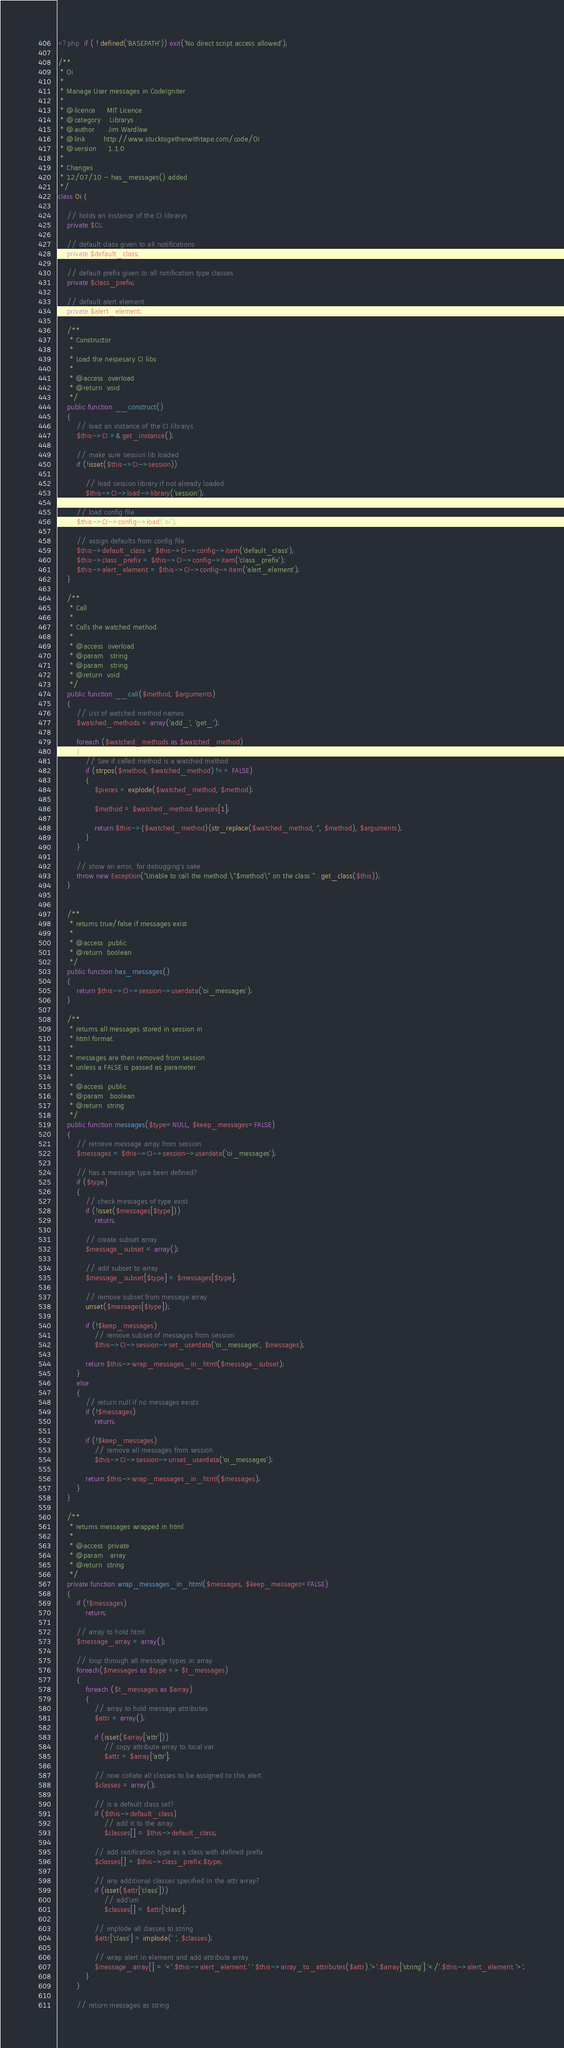<code> <loc_0><loc_0><loc_500><loc_500><_PHP_><?php  if ( ! defined('BASEPATH')) exit('No direct script access allowed');

/**
 * Oi
 *
 * Manage User messages in CodeIgniter
 *
 * @licence 	MIT Licence
 * @category	Librarys 
 * @author		Jim Wardlaw
 * @link		http://www.stucktogetherwithtape.com/code/Oi
 * @version 	1.1.0
 *
 * Changes
 * 12/07/10	- has_messages() added
 */ 
class Oi {
	
	// holds an instance of the CI librarys
	private $CI; 		

	// default class given to all notifications
	private $default_class;
	
	// default prefix given to all notification type classes
	private $class_prefix;
	
	// default alert element
	private $alert_element;

	/**
	 * Constructor
	 *
	 * Load the nessesary CI libs
	 *
	 * @access	overload
	 * @return	void
	 */	
	public function __construct()
	{
		// load an instance of the CI librarys
		$this->CI =& get_instance();
		
		// make sure session lib loaded
		if (!isset($this->CI->session))
		
			// load session library if not already loaded
			$this->CI->load->library('session');
			
		// load config file
		$this->CI->config->load('oi');
		
		// assign defaults from config file
		$this->default_class = $this->CI->config->item('default_class');		
		$this->class_prefix = $this->CI->config->item('class_prefix');		
		$this->alert_element = $this->CI->config->item('alert_element');
	}
	
	/**
	 * Call
	 *
	 * Calls the watched method.
	 *
	 * @access	overload
	 * @param	string
	 * @param	string
	 * @return	void
	 */
	public function __call($method, $arguments)
	{		
		// List of watched method names
		$watched_methods = array('add_', 'get_');

		foreach ($watched_methods as $watched_method)
		{
			// See if called method is a watched method
			if (strpos($method, $watched_method) !== FALSE)
			{
				$pieces = explode($watched_method, $method);
				
				$method = $watched_method.$pieces[1];
								
				return $this->{$watched_method}(str_replace($watched_method, '', $method), $arguments);
			}
		}
				
		// show an error, for debugging's sake.
		throw new Exception("Unable to call the method \"$method\" on the class " . get_class($this));
	}


	/**
	 * returns true/false if messages exist
	 *
	 * @access	public
	 * @return	boolean
	 */
	public function has_messages()
	{
		return $this->CI->session->userdata('oi_messages');
	}

	/**
	 * returns all messages stored in session in
	 * html format.
	 *
	 * messages are then removed from session
	 * unless a FALSE is passed as parameter
	 *
	 * @access	public
	 * @param	boolean
	 * @return	string
	 */
	public function messages($type=NULL, $keep_messages=FALSE)
	{
		// retrieve message array from session
		$messages = $this->CI->session->userdata('oi_messages');
		
		// has a message type been defined?
		if ($type)
		{
			// check messages of type exist
			if (!isset($messages[$type]))
				return;
			
			// create subset array
			$message_subset = array();
			
			// add subset to array
			$message_subset[$type] = $messages[$type];
			
			// remove subset from message array
			unset($messages[$type]);
			
			if (!$keep_messages)
				// remove subset of messages from session
				$this->CI->session->set_userdata('oi_messages', $messages);
			
			return $this->wrap_messages_in_html($message_subset);				
		}
		else
		{
			// return null if no messages exists
			if (!$messages)
				return;
				
			if (!$keep_messages)
				// remove all messages from session
				$this->CI->session->unset_userdata('oi_messages');
				
			return $this->wrap_messages_in_html($messages);
		}
	}

	/**
	 * returns messages wrapped in html
	 *
	 * @access	private
	 * @param	array
	 * @return	string
	 */	
	private function wrap_messages_in_html($messages, $keep_messages=FALSE)
	{
		if (!$messages)
			return;
			
		// array to hold html
		$message_array = array();
			
		// loop through all message types in array
		foreach($messages as $type => $t_messages)
		{			
			foreach ($t_messages as $array)
			{
				// array to hold message attributes
				$attr = array();
							
				if (isset($array['attr']))
					// copy attribute array to local var
					$attr = $array['attr'];
					
				// now collate all classes to be assigned to this alert
				$classes = array();
				
				// is a default class set?
				if ($this->default_class)
					// add it to the array
					$classes[] = $this->default_class;
					
				// add notification type as a class with defined prefix
				$classes[] = $this->class_prefix.$type;
				
				// any additional classes specified in the attr array?
				if (isset($attr['class']))
					// add'um
					$classes[] = $attr['class'];
				
				// implode all classes to string
				$attr['class'] = implode(' ', $classes);
							
				// wrap alert in element and add attribute array
				$message_array[] = '<'.$this->alert_element.' '.$this->array_to_attributes($attr).'>'.$array['string'].'</'.$this->alert_element.'>';
			}
		}
						
		// return messages as string</code> 